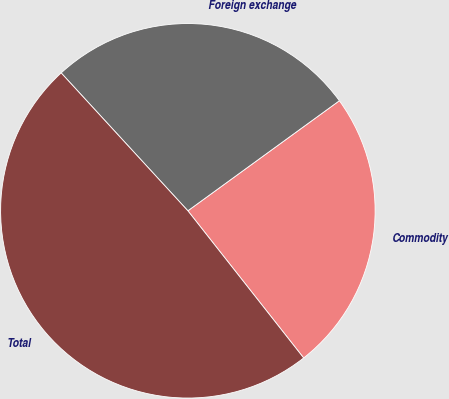<chart> <loc_0><loc_0><loc_500><loc_500><pie_chart><fcel>Commodity<fcel>Foreign exchange<fcel>Total<nl><fcel>24.39%<fcel>26.83%<fcel>48.78%<nl></chart> 